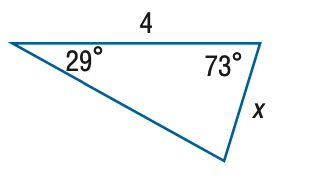Answer the mathemtical geometry problem and directly provide the correct option letter.
Question: Find x. Round side measure to the nearest tenth.
Choices: A: 2.0 B: 4.1 C: 7.9 D: 8.1 A 